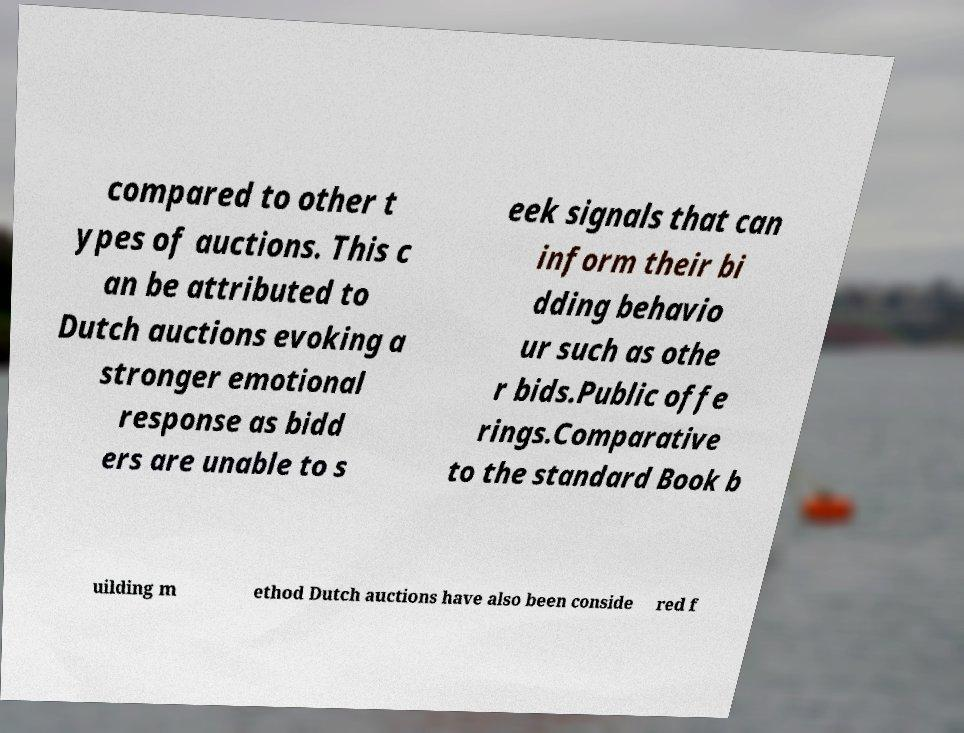Please identify and transcribe the text found in this image. compared to other t ypes of auctions. This c an be attributed to Dutch auctions evoking a stronger emotional response as bidd ers are unable to s eek signals that can inform their bi dding behavio ur such as othe r bids.Public offe rings.Comparative to the standard Book b uilding m ethod Dutch auctions have also been conside red f 